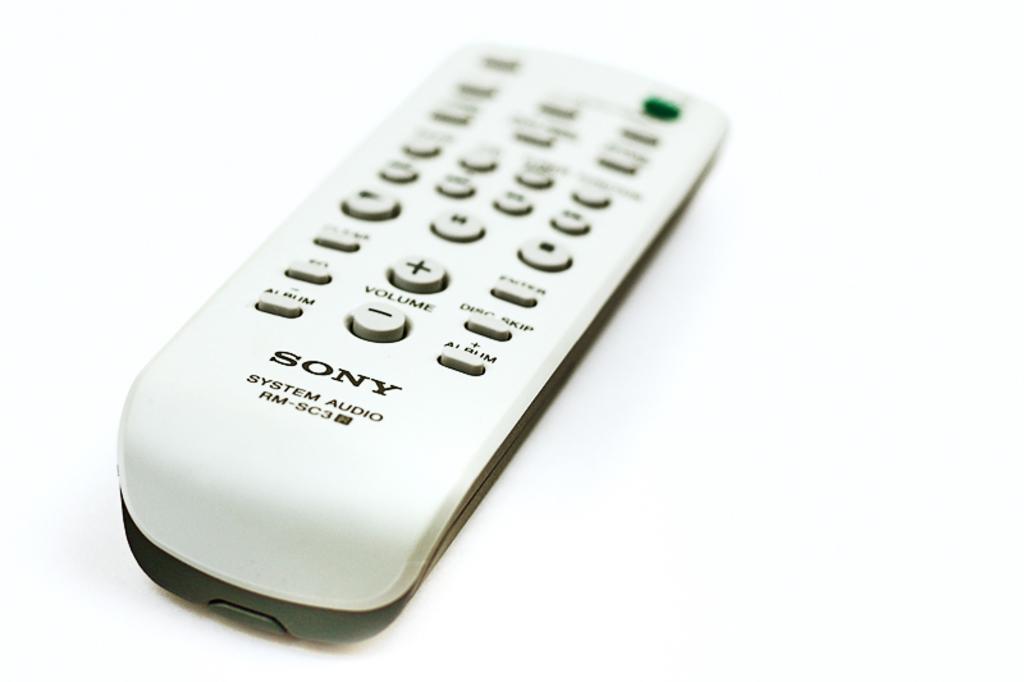In one or two sentences, can you explain what this image depicts? In this image we can see a remote which is placed on the surface. 